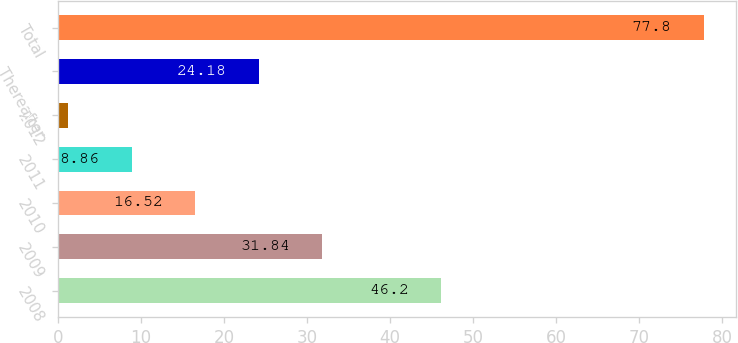Convert chart to OTSL. <chart><loc_0><loc_0><loc_500><loc_500><bar_chart><fcel>2008<fcel>2009<fcel>2010<fcel>2011<fcel>2012<fcel>Thereafter<fcel>Total<nl><fcel>46.2<fcel>31.84<fcel>16.52<fcel>8.86<fcel>1.2<fcel>24.18<fcel>77.8<nl></chart> 